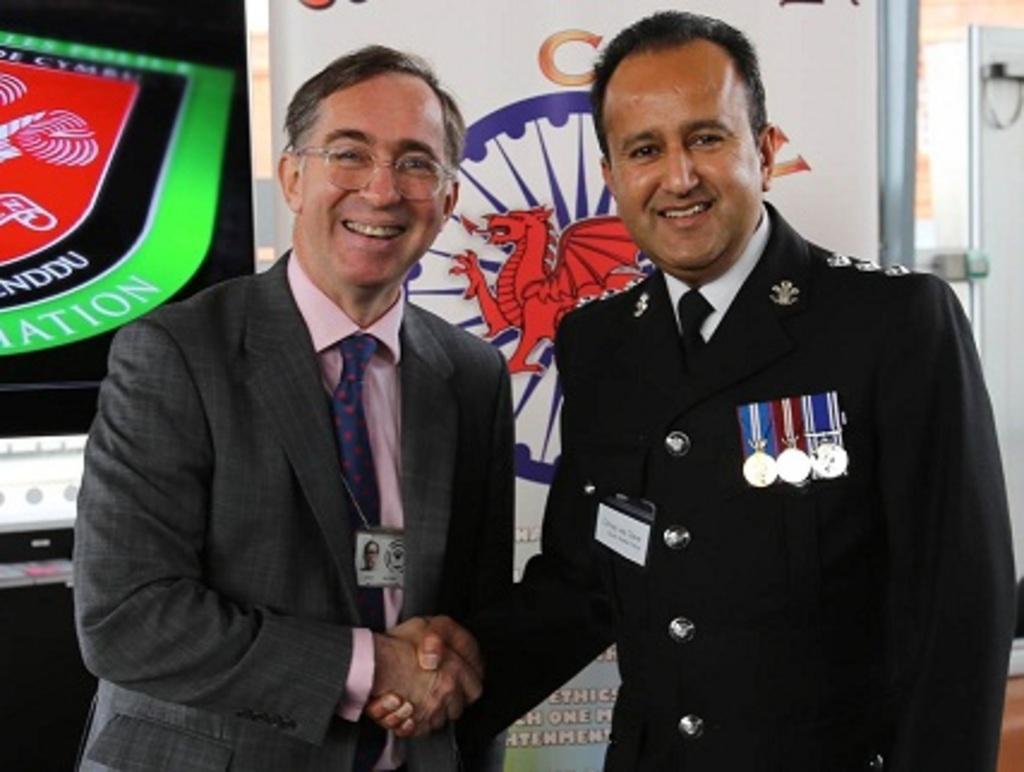Could you give a brief overview of what you see in this image? In this picture we can see two people, they are smiling and in the background we can see posters and some objects. 